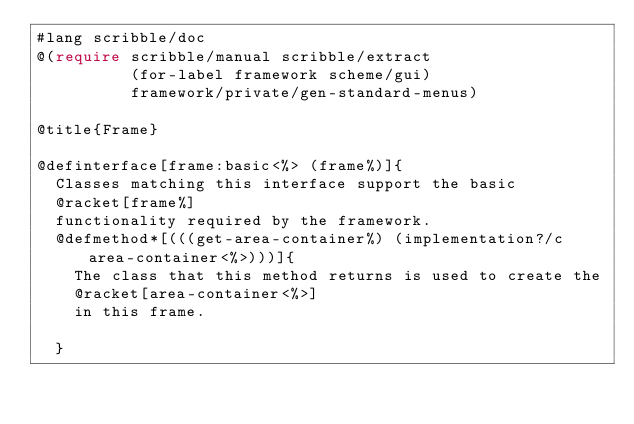<code> <loc_0><loc_0><loc_500><loc_500><_Racket_>#lang scribble/doc 
@(require scribble/manual scribble/extract
          (for-label framework scheme/gui)
          framework/private/gen-standard-menus)

@title{Frame}

@definterface[frame:basic<%> (frame%)]{
  Classes matching this interface support the basic 
  @racket[frame%]
  functionality required by the framework.
  @defmethod*[(((get-area-container%) (implementation?/c area-container<%>)))]{
    The class that this method returns is used to create the
    @racket[area-container<%>]
    in this frame.

  }</code> 